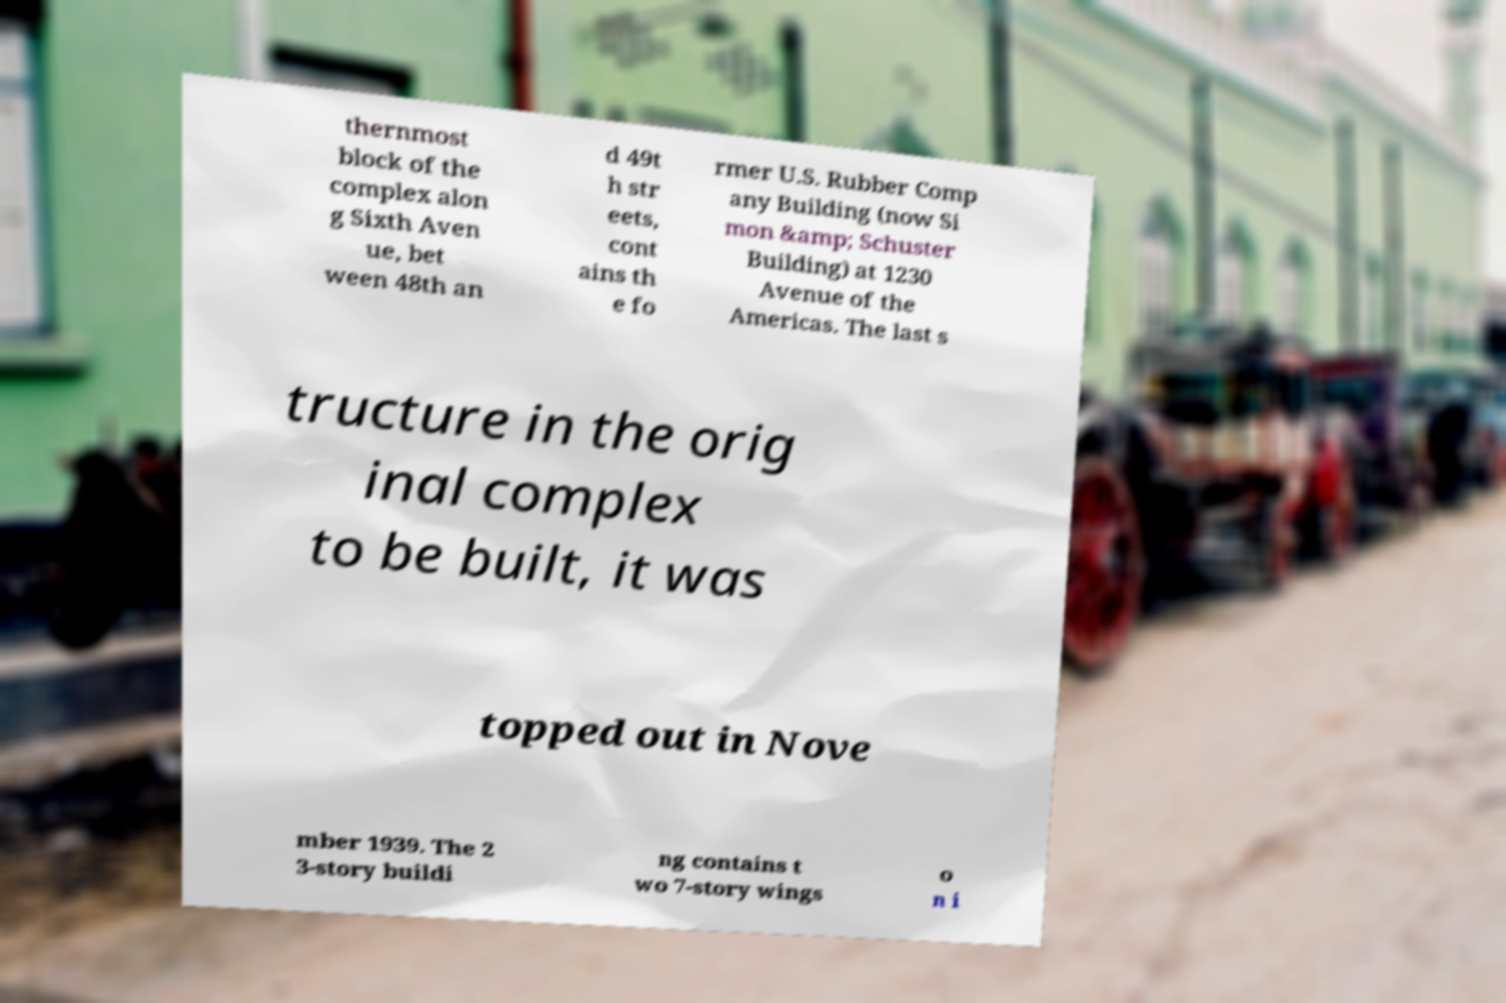What messages or text are displayed in this image? I need them in a readable, typed format. thernmost block of the complex alon g Sixth Aven ue, bet ween 48th an d 49t h str eets, cont ains th e fo rmer U.S. Rubber Comp any Building (now Si mon &amp; Schuster Building) at 1230 Avenue of the Americas. The last s tructure in the orig inal complex to be built, it was topped out in Nove mber 1939. The 2 3-story buildi ng contains t wo 7-story wings o n i 